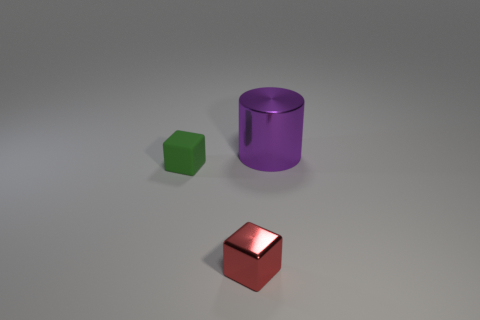How many balls are purple objects or shiny objects?
Make the answer very short. 0. The tiny rubber object is what color?
Your answer should be compact. Green. Are there more green rubber objects than large cyan metal blocks?
Your answer should be compact. Yes. How many objects are either things that are left of the big purple shiny cylinder or small green shiny balls?
Give a very brief answer. 2. Is the material of the purple thing the same as the green object?
Provide a succinct answer. No. There is a metallic object that is the same shape as the tiny matte thing; what size is it?
Ensure brevity in your answer.  Small. There is a shiny object that is in front of the big purple cylinder; is it the same shape as the shiny object behind the tiny green object?
Ensure brevity in your answer.  No. There is a matte object; is its size the same as the object that is in front of the small green rubber cube?
Your answer should be very brief. Yes. What number of other objects are the same material as the red cube?
Your response must be concise. 1. Is there anything else that has the same shape as the big purple shiny object?
Provide a short and direct response. No. 